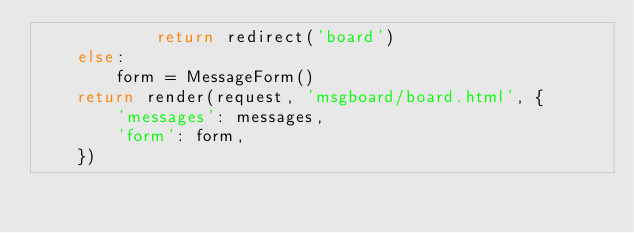Convert code to text. <code><loc_0><loc_0><loc_500><loc_500><_Python_>            return redirect('board')
    else:
        form = MessageForm()
    return render(request, 'msgboard/board.html', {
        'messages': messages,
        'form': form,
    })
</code> 